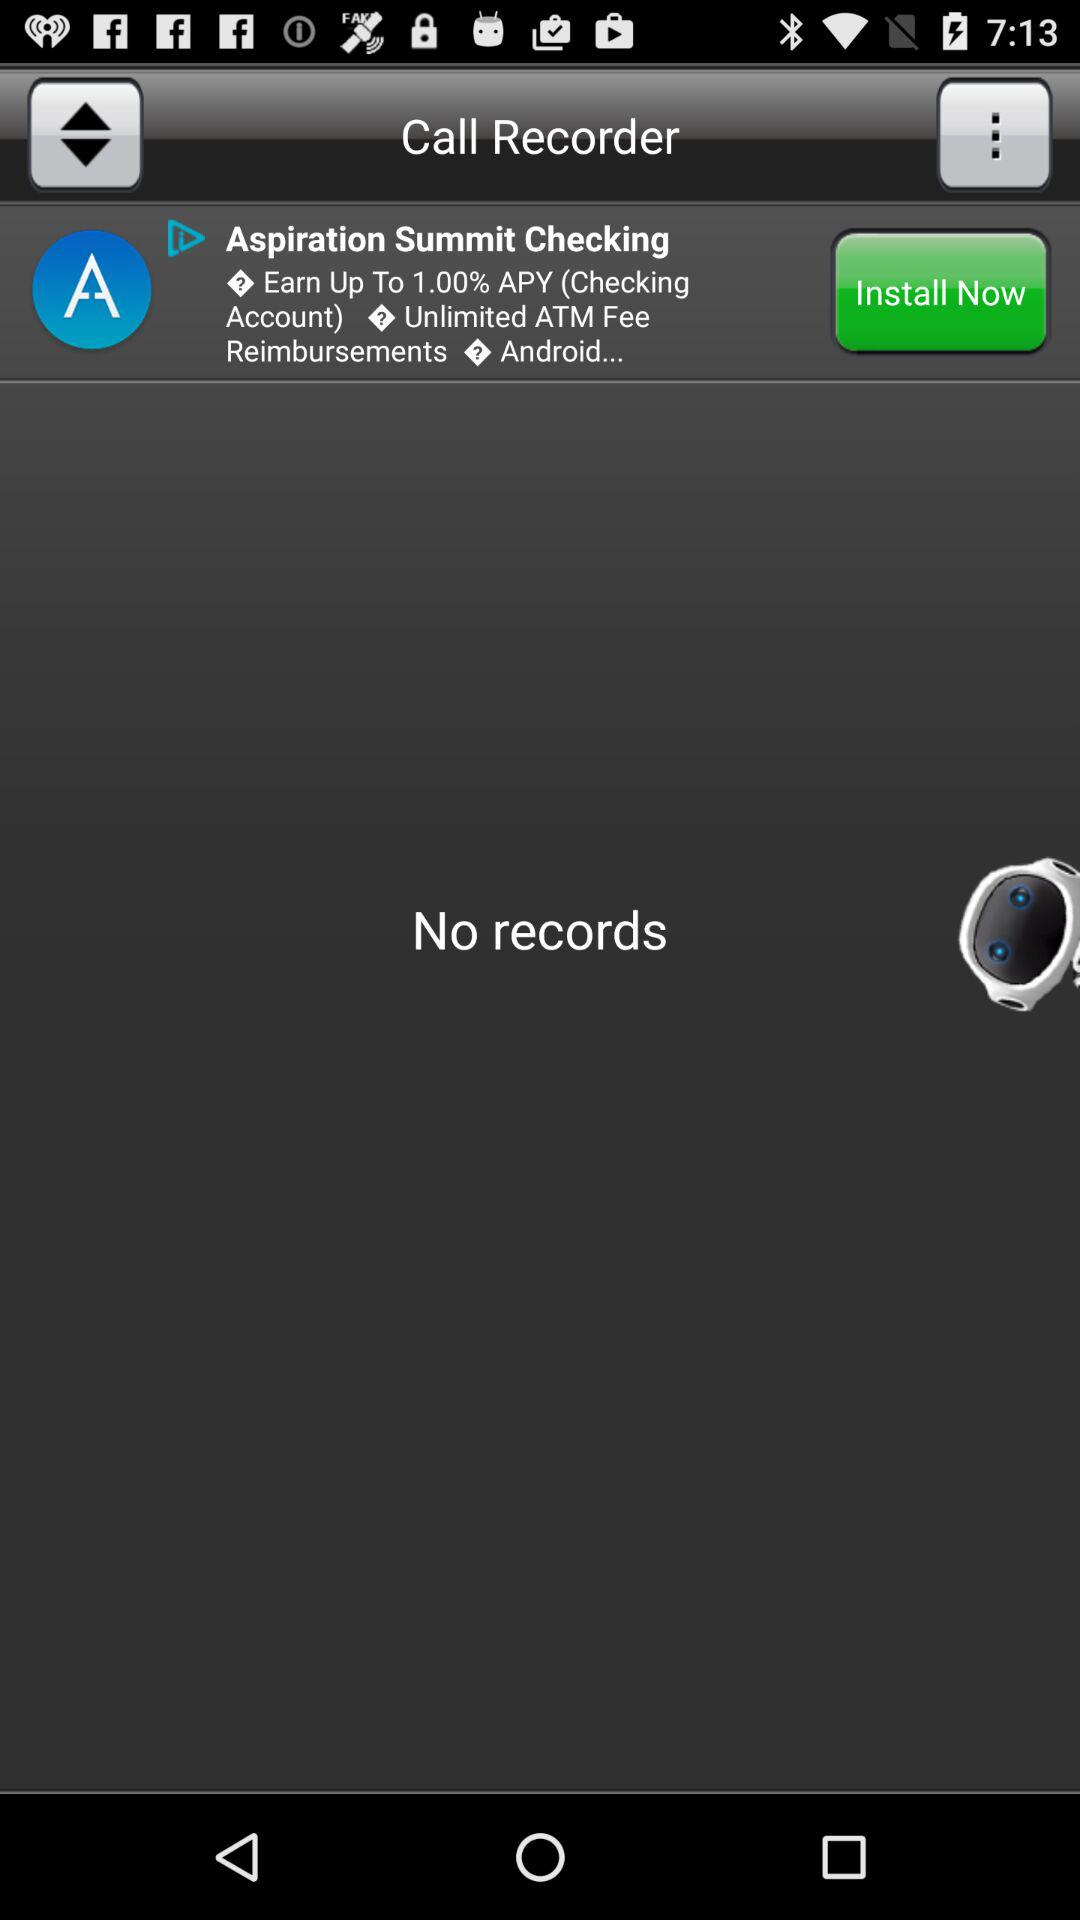What is the application name? The application name is "Call Recorder". 